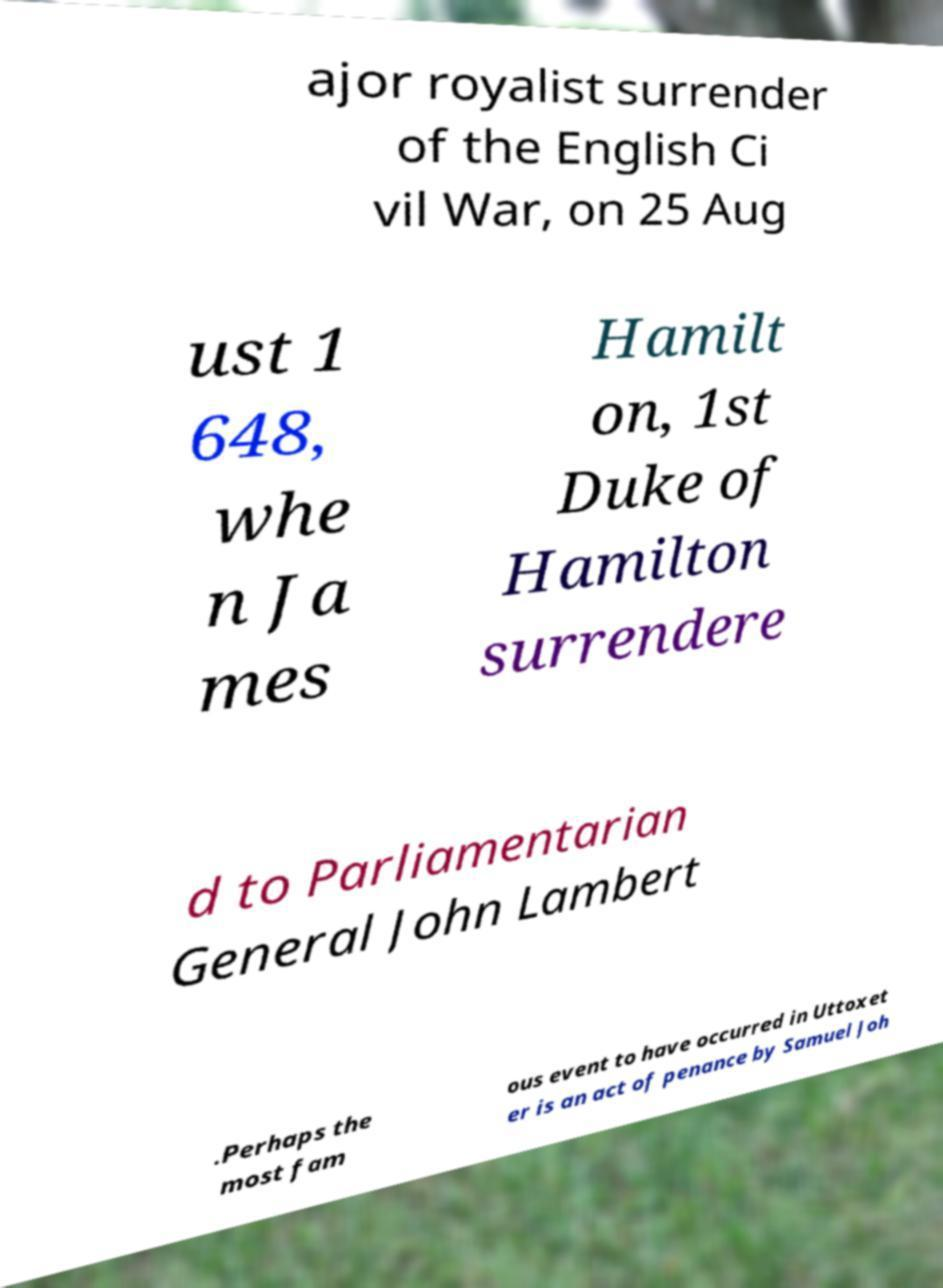What messages or text are displayed in this image? I need them in a readable, typed format. ajor royalist surrender of the English Ci vil War, on 25 Aug ust 1 648, whe n Ja mes Hamilt on, 1st Duke of Hamilton surrendere d to Parliamentarian General John Lambert .Perhaps the most fam ous event to have occurred in Uttoxet er is an act of penance by Samuel Joh 